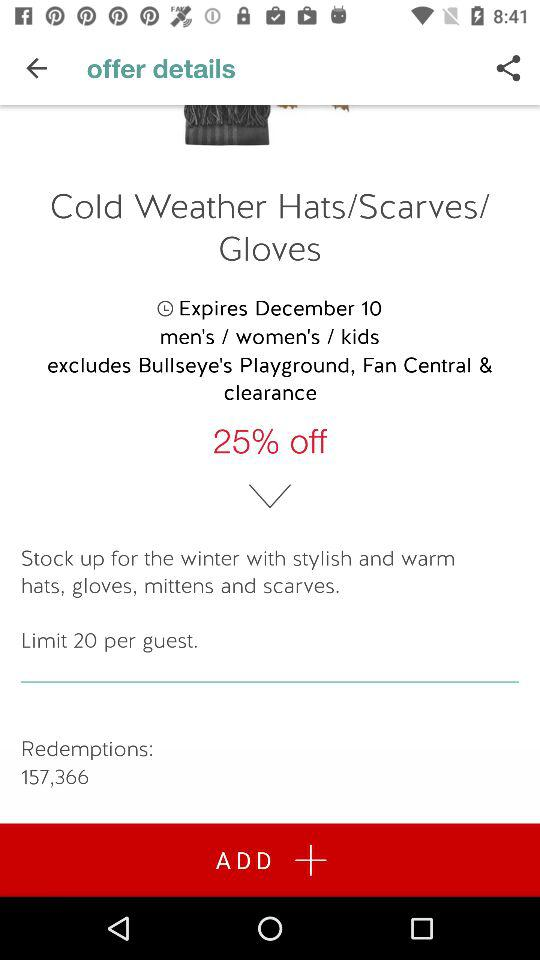What is the limit of this offer?
Answer the question using a single word or phrase. 20 per guest 